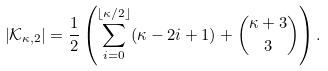Convert formula to latex. <formula><loc_0><loc_0><loc_500><loc_500>\left | \mathcal { K } _ { \kappa , 2 } \right | = \frac { 1 } { 2 } \left ( \sum _ { i = 0 } ^ { \lfloor \kappa / 2 \rfloor } ( \kappa - 2 i + 1 ) + \binom { \kappa + 3 } { 3 } \right ) .</formula> 